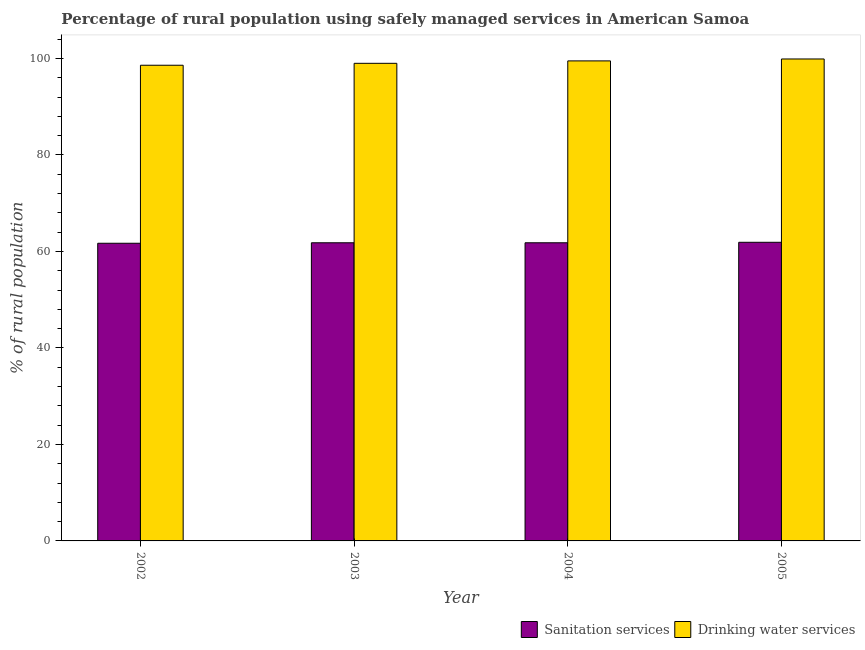How many different coloured bars are there?
Keep it short and to the point. 2. How many groups of bars are there?
Provide a short and direct response. 4. Are the number of bars per tick equal to the number of legend labels?
Make the answer very short. Yes. How many bars are there on the 4th tick from the left?
Give a very brief answer. 2. What is the label of the 1st group of bars from the left?
Your answer should be very brief. 2002. In how many cases, is the number of bars for a given year not equal to the number of legend labels?
Offer a very short reply. 0. What is the percentage of rural population who used drinking water services in 2002?
Your response must be concise. 98.6. Across all years, what is the maximum percentage of rural population who used sanitation services?
Provide a short and direct response. 61.9. Across all years, what is the minimum percentage of rural population who used sanitation services?
Your answer should be very brief. 61.7. In which year was the percentage of rural population who used drinking water services maximum?
Make the answer very short. 2005. In which year was the percentage of rural population who used drinking water services minimum?
Offer a very short reply. 2002. What is the total percentage of rural population who used drinking water services in the graph?
Keep it short and to the point. 397. What is the difference between the percentage of rural population who used drinking water services in 2003 and that in 2005?
Offer a very short reply. -0.9. What is the difference between the percentage of rural population who used drinking water services in 2005 and the percentage of rural population who used sanitation services in 2004?
Provide a short and direct response. 0.4. What is the average percentage of rural population who used drinking water services per year?
Provide a succinct answer. 99.25. In the year 2005, what is the difference between the percentage of rural population who used sanitation services and percentage of rural population who used drinking water services?
Your answer should be compact. 0. In how many years, is the percentage of rural population who used sanitation services greater than 12 %?
Make the answer very short. 4. What is the ratio of the percentage of rural population who used drinking water services in 2002 to that in 2005?
Make the answer very short. 0.99. Is the percentage of rural population who used sanitation services in 2004 less than that in 2005?
Give a very brief answer. Yes. What is the difference between the highest and the second highest percentage of rural population who used drinking water services?
Keep it short and to the point. 0.4. What is the difference between the highest and the lowest percentage of rural population who used sanitation services?
Offer a very short reply. 0.2. What does the 1st bar from the left in 2002 represents?
Your response must be concise. Sanitation services. What does the 1st bar from the right in 2005 represents?
Your response must be concise. Drinking water services. Are all the bars in the graph horizontal?
Provide a short and direct response. No. How many years are there in the graph?
Your answer should be compact. 4. What is the difference between two consecutive major ticks on the Y-axis?
Make the answer very short. 20. Does the graph contain any zero values?
Provide a short and direct response. No. Where does the legend appear in the graph?
Offer a very short reply. Bottom right. How many legend labels are there?
Give a very brief answer. 2. What is the title of the graph?
Your answer should be compact. Percentage of rural population using safely managed services in American Samoa. What is the label or title of the Y-axis?
Provide a succinct answer. % of rural population. What is the % of rural population in Sanitation services in 2002?
Offer a terse response. 61.7. What is the % of rural population of Drinking water services in 2002?
Your answer should be very brief. 98.6. What is the % of rural population of Sanitation services in 2003?
Keep it short and to the point. 61.8. What is the % of rural population of Sanitation services in 2004?
Make the answer very short. 61.8. What is the % of rural population of Drinking water services in 2004?
Ensure brevity in your answer.  99.5. What is the % of rural population of Sanitation services in 2005?
Your answer should be very brief. 61.9. What is the % of rural population of Drinking water services in 2005?
Keep it short and to the point. 99.9. Across all years, what is the maximum % of rural population in Sanitation services?
Ensure brevity in your answer.  61.9. Across all years, what is the maximum % of rural population in Drinking water services?
Keep it short and to the point. 99.9. Across all years, what is the minimum % of rural population of Sanitation services?
Your answer should be very brief. 61.7. Across all years, what is the minimum % of rural population of Drinking water services?
Offer a terse response. 98.6. What is the total % of rural population of Sanitation services in the graph?
Offer a terse response. 247.2. What is the total % of rural population of Drinking water services in the graph?
Ensure brevity in your answer.  397. What is the difference between the % of rural population of Drinking water services in 2002 and that in 2003?
Offer a very short reply. -0.4. What is the difference between the % of rural population in Sanitation services in 2002 and that in 2004?
Ensure brevity in your answer.  -0.1. What is the difference between the % of rural population of Sanitation services in 2002 and that in 2005?
Keep it short and to the point. -0.2. What is the difference between the % of rural population of Drinking water services in 2002 and that in 2005?
Ensure brevity in your answer.  -1.3. What is the difference between the % of rural population of Sanitation services in 2003 and that in 2004?
Give a very brief answer. 0. What is the difference between the % of rural population of Drinking water services in 2003 and that in 2004?
Give a very brief answer. -0.5. What is the difference between the % of rural population in Sanitation services in 2002 and the % of rural population in Drinking water services in 2003?
Your answer should be very brief. -37.3. What is the difference between the % of rural population in Sanitation services in 2002 and the % of rural population in Drinking water services in 2004?
Give a very brief answer. -37.8. What is the difference between the % of rural population in Sanitation services in 2002 and the % of rural population in Drinking water services in 2005?
Offer a very short reply. -38.2. What is the difference between the % of rural population in Sanitation services in 2003 and the % of rural population in Drinking water services in 2004?
Ensure brevity in your answer.  -37.7. What is the difference between the % of rural population of Sanitation services in 2003 and the % of rural population of Drinking water services in 2005?
Your response must be concise. -38.1. What is the difference between the % of rural population in Sanitation services in 2004 and the % of rural population in Drinking water services in 2005?
Provide a short and direct response. -38.1. What is the average % of rural population of Sanitation services per year?
Offer a very short reply. 61.8. What is the average % of rural population of Drinking water services per year?
Offer a terse response. 99.25. In the year 2002, what is the difference between the % of rural population in Sanitation services and % of rural population in Drinking water services?
Provide a short and direct response. -36.9. In the year 2003, what is the difference between the % of rural population in Sanitation services and % of rural population in Drinking water services?
Give a very brief answer. -37.2. In the year 2004, what is the difference between the % of rural population in Sanitation services and % of rural population in Drinking water services?
Ensure brevity in your answer.  -37.7. In the year 2005, what is the difference between the % of rural population in Sanitation services and % of rural population in Drinking water services?
Ensure brevity in your answer.  -38. What is the ratio of the % of rural population in Drinking water services in 2002 to that in 2003?
Your answer should be compact. 1. What is the ratio of the % of rural population in Drinking water services in 2002 to that in 2004?
Make the answer very short. 0.99. What is the ratio of the % of rural population in Sanitation services in 2003 to that in 2005?
Give a very brief answer. 1. What is the ratio of the % of rural population of Drinking water services in 2004 to that in 2005?
Your answer should be very brief. 1. What is the difference between the highest and the second highest % of rural population in Sanitation services?
Keep it short and to the point. 0.1. What is the difference between the highest and the lowest % of rural population in Drinking water services?
Offer a very short reply. 1.3. 